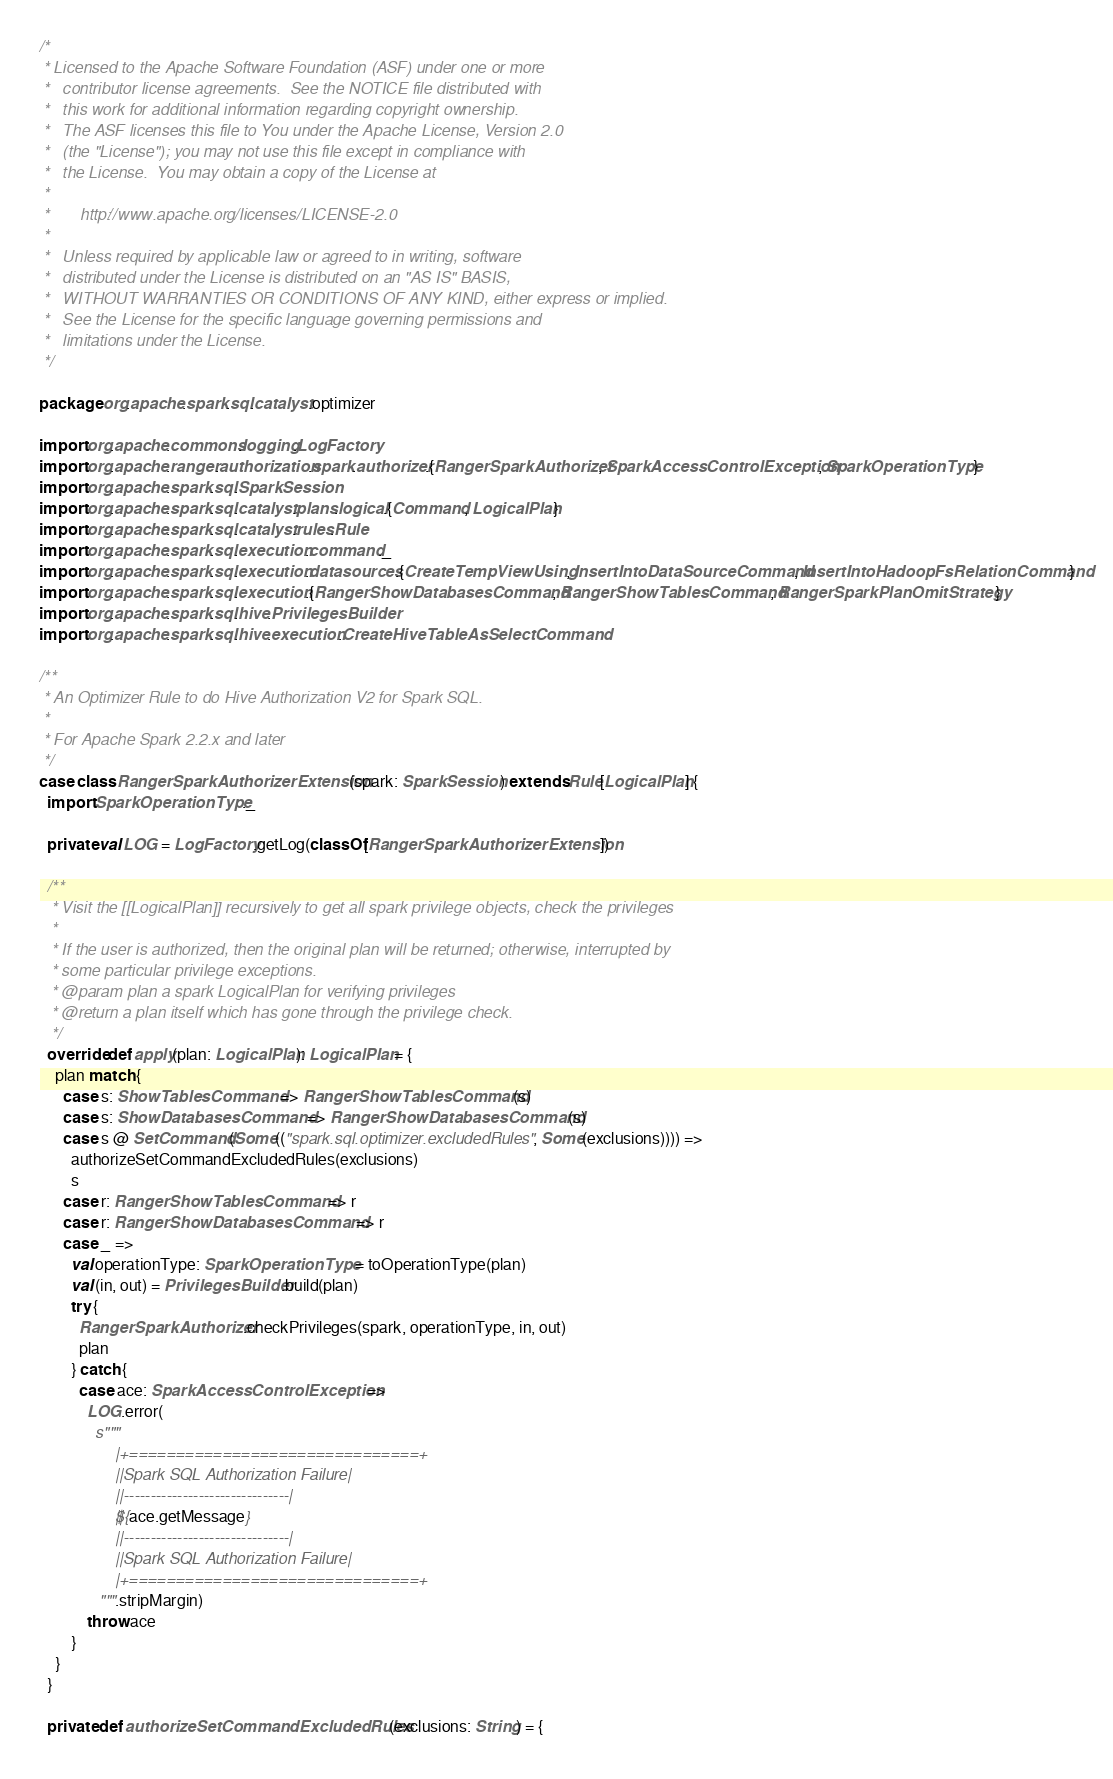<code> <loc_0><loc_0><loc_500><loc_500><_Scala_>/*
 * Licensed to the Apache Software Foundation (ASF) under one or more
 *   contributor license agreements.  See the NOTICE file distributed with
 *   this work for additional information regarding copyright ownership.
 *   The ASF licenses this file to You under the Apache License, Version 2.0
 *   (the "License"); you may not use this file except in compliance with
 *   the License.  You may obtain a copy of the License at
 *
 *       http://www.apache.org/licenses/LICENSE-2.0
 *
 *   Unless required by applicable law or agreed to in writing, software
 *   distributed under the License is distributed on an "AS IS" BASIS,
 *   WITHOUT WARRANTIES OR CONDITIONS OF ANY KIND, either express or implied.
 *   See the License for the specific language governing permissions and
 *   limitations under the License.
 */

package org.apache.spark.sql.catalyst.optimizer

import org.apache.commons.logging.LogFactory
import org.apache.ranger.authorization.spark.authorizer.{RangerSparkAuthorizer, SparkAccessControlException, SparkOperationType}
import org.apache.spark.sql.SparkSession
import org.apache.spark.sql.catalyst.plans.logical.{Command, LogicalPlan}
import org.apache.spark.sql.catalyst.rules.Rule
import org.apache.spark.sql.execution.command._
import org.apache.spark.sql.execution.datasources.{CreateTempViewUsing, InsertIntoDataSourceCommand, InsertIntoHadoopFsRelationCommand}
import org.apache.spark.sql.execution.{RangerShowDatabasesCommand, RangerShowTablesCommand, RangerSparkPlanOmitStrategy}
import org.apache.spark.sql.hive.PrivilegesBuilder
import org.apache.spark.sql.hive.execution.CreateHiveTableAsSelectCommand

/**
 * An Optimizer Rule to do Hive Authorization V2 for Spark SQL.
 *
 * For Apache Spark 2.2.x and later
 */
case class RangerSparkAuthorizerExtension(spark: SparkSession) extends Rule[LogicalPlan] {
  import SparkOperationType._

  private val LOG = LogFactory.getLog(classOf[RangerSparkAuthorizerExtension])

  /**
   * Visit the [[LogicalPlan]] recursively to get all spark privilege objects, check the privileges
   *
   * If the user is authorized, then the original plan will be returned; otherwise, interrupted by
   * some particular privilege exceptions.
   * @param plan a spark LogicalPlan for verifying privileges
   * @return a plan itself which has gone through the privilege check.
   */
  override def apply(plan: LogicalPlan): LogicalPlan = {
    plan match {
      case s: ShowTablesCommand => RangerShowTablesCommand(s)
      case s: ShowDatabasesCommand => RangerShowDatabasesCommand(s)
      case s @ SetCommand(Some(("spark.sql.optimizer.excludedRules", Some(exclusions)))) =>
        authorizeSetCommandExcludedRules(exclusions)
        s
      case r: RangerShowTablesCommand => r
      case r: RangerShowDatabasesCommand => r
      case _ =>
        val operationType: SparkOperationType = toOperationType(plan)
        val (in, out) = PrivilegesBuilder.build(plan)
        try {
          RangerSparkAuthorizer.checkPrivileges(spark, operationType, in, out)
          plan
        } catch {
          case ace: SparkAccessControlException =>
            LOG.error(
              s"""
                 |+===============================+
                 ||Spark SQL Authorization Failure|
                 ||-------------------------------|
                 ||${ace.getMessage}
                 ||-------------------------------|
                 ||Spark SQL Authorization Failure|
                 |+===============================+
               """.stripMargin)
            throw ace
        }
    }
  }

  private def authorizeSetCommandExcludedRules(exclusions: String) = {</code> 